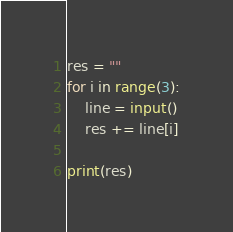<code> <loc_0><loc_0><loc_500><loc_500><_Python_>res = ""
for i in range(3):
    line = input()
    res += line[i]

print(res)
</code> 